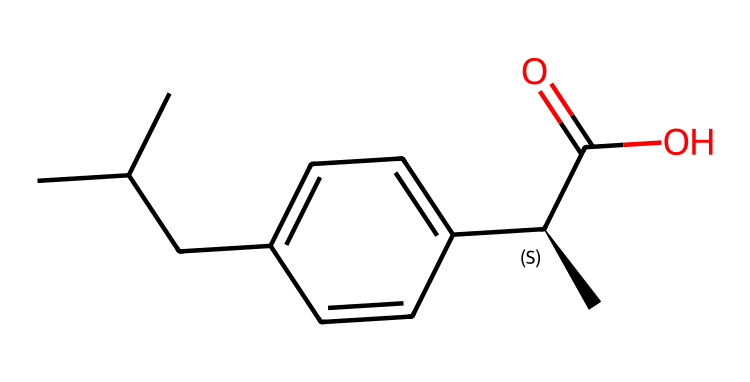What is the molecular formula of ibuprofen? The SMILES representation can be translated to its molecular formula by counting the various atoms present. By analyzing it, we can see it has 13 carbons (C), 18 hydrogens (H), and 2 oxygens (O).
Answer: C13H18O2 How many chiral centers are present in ibuprofen? In the provided SMILES structure, 'C@H' indicates a chiral center. Therefore, there is one chiral center in ibuprofen.
Answer: 1 What functional group is present in ibuprofen? The molecule contains a carboxylic acid functional group, seen in the part 'C(=O)O'. This indicates the presence of a carbonyl (C=O) and a hydroxyl (–OH) group, characteristic of carboxylic acids.
Answer: carboxylic acid Which part of ibuprofen contributes to its anti-inflammatory properties? The presence of the aromatic ring structure (indicated by 'c' in the SMILES) and the carboxylic acid both play roles in its activity as an anti-inflammatory, specifically in inhibiting cyclooxygenase enzymes (COX).
Answer: aromatic ring and carboxylic acid What is the importance of the chiral center in ibuprofen? The chiral center in ibuprofen makes it a chiral compound, leading to different enantiomers that can have different biological activities. The S-enantiomer is typically the active form, affecting its therapeutic efficacy.
Answer: different biological activities How many hydrogen atoms are attached to the chiral carbon? By analyzing the structure around the chiral carbon ('C@H'), it can be seen that there are two hydrogen atoms attached, alongside other substituents.
Answer: 2 What does the presence of the chiral center suggest about ibuprofen's pharmacokinetics? The presence of a chiral center suggests that ibuprofen may have enantiomers that are metabolized differently, affecting its absorption, distribution, metabolism, and excretion (ADME) properties in the body.
Answer: varied metabolism 